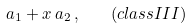Convert formula to latex. <formula><loc_0><loc_0><loc_500><loc_500>a _ { 1 } + x \, a _ { 2 } \, , \quad ( c l a s s I I I )</formula> 